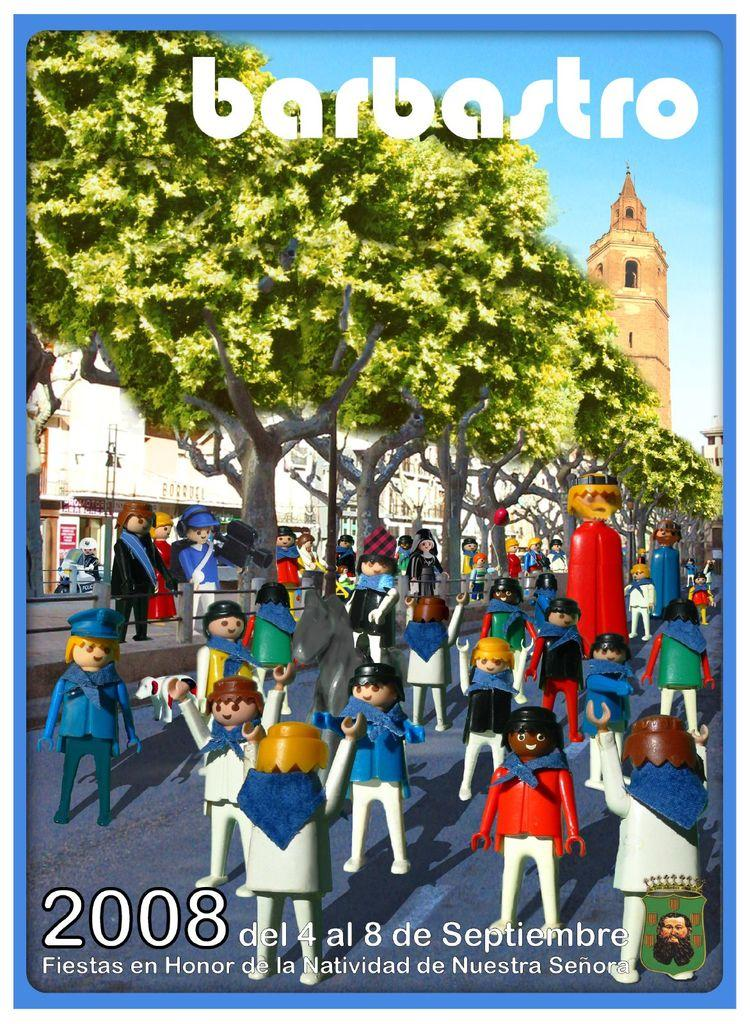Provide a one-sentence caption for the provided image. Barbastro play people standing around outside in 2008. 